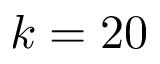<formula> <loc_0><loc_0><loc_500><loc_500>k = 2 0</formula> 